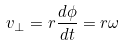<formula> <loc_0><loc_0><loc_500><loc_500>v _ { \perp } = r \frac { d \phi } { d t } = r \omega</formula> 